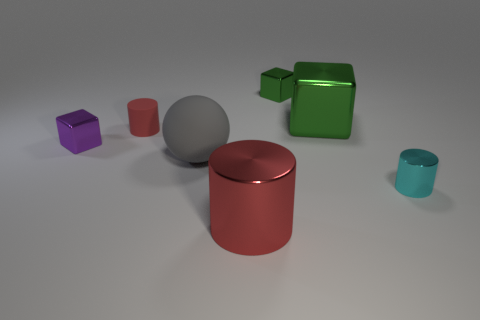Add 3 large yellow metallic things. How many objects exist? 10 Subtract all tiny green metal blocks. How many blocks are left? 2 Subtract all green blocks. How many blocks are left? 1 Subtract all balls. How many objects are left? 6 Subtract 1 cylinders. How many cylinders are left? 2 Subtract all yellow cylinders. Subtract all cyan blocks. How many cylinders are left? 3 Subtract all blue balls. How many cyan cylinders are left? 1 Subtract all big brown balls. Subtract all matte spheres. How many objects are left? 6 Add 6 large gray objects. How many large gray objects are left? 7 Add 5 gray rubber objects. How many gray rubber objects exist? 6 